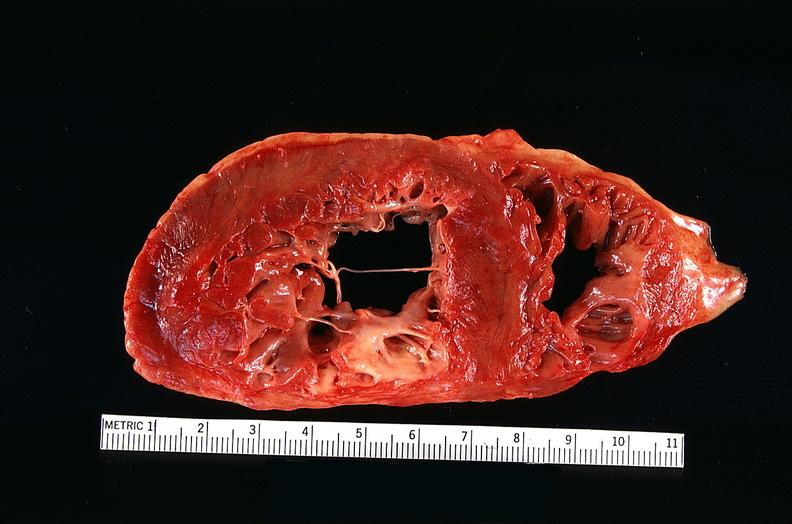does infant body show congestive heart failure, three vessel coronary artery disease?
Answer the question using a single word or phrase. No 